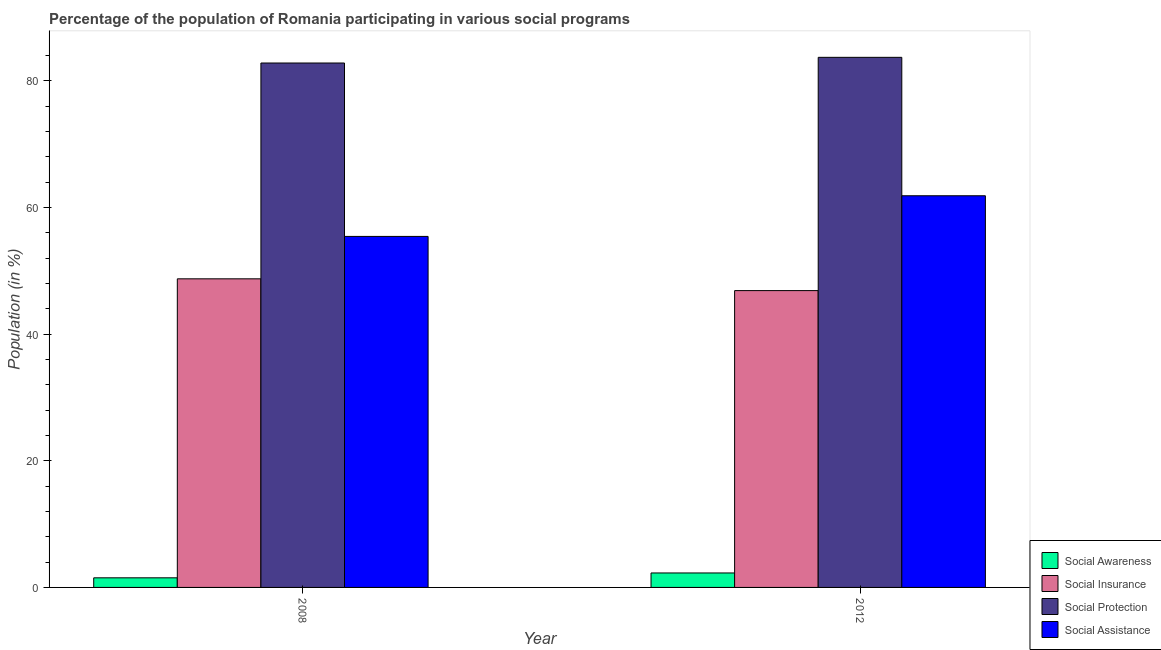How many groups of bars are there?
Offer a very short reply. 2. Are the number of bars per tick equal to the number of legend labels?
Offer a terse response. Yes. How many bars are there on the 1st tick from the left?
Ensure brevity in your answer.  4. What is the label of the 1st group of bars from the left?
Offer a very short reply. 2008. What is the participation of population in social protection programs in 2012?
Offer a terse response. 83.69. Across all years, what is the maximum participation of population in social awareness programs?
Offer a very short reply. 2.28. Across all years, what is the minimum participation of population in social insurance programs?
Your answer should be very brief. 46.86. What is the total participation of population in social awareness programs in the graph?
Offer a very short reply. 3.8. What is the difference between the participation of population in social protection programs in 2008 and that in 2012?
Provide a succinct answer. -0.9. What is the difference between the participation of population in social protection programs in 2008 and the participation of population in social assistance programs in 2012?
Provide a short and direct response. -0.9. What is the average participation of population in social insurance programs per year?
Provide a succinct answer. 47.79. In the year 2012, what is the difference between the participation of population in social awareness programs and participation of population in social insurance programs?
Keep it short and to the point. 0. In how many years, is the participation of population in social assistance programs greater than 72 %?
Offer a terse response. 0. What is the ratio of the participation of population in social awareness programs in 2008 to that in 2012?
Ensure brevity in your answer.  0.66. Is the participation of population in social insurance programs in 2008 less than that in 2012?
Ensure brevity in your answer.  No. In how many years, is the participation of population in social awareness programs greater than the average participation of population in social awareness programs taken over all years?
Offer a very short reply. 1. Is it the case that in every year, the sum of the participation of population in social assistance programs and participation of population in social insurance programs is greater than the sum of participation of population in social protection programs and participation of population in social awareness programs?
Keep it short and to the point. Yes. What does the 1st bar from the left in 2012 represents?
Your answer should be very brief. Social Awareness. What does the 3rd bar from the right in 2008 represents?
Ensure brevity in your answer.  Social Insurance. Are all the bars in the graph horizontal?
Your answer should be very brief. No. Does the graph contain grids?
Offer a very short reply. No. What is the title of the graph?
Give a very brief answer. Percentage of the population of Romania participating in various social programs . Does "Subsidies and Transfers" appear as one of the legend labels in the graph?
Provide a short and direct response. No. What is the Population (in %) of Social Awareness in 2008?
Provide a succinct answer. 1.52. What is the Population (in %) in Social Insurance in 2008?
Offer a terse response. 48.72. What is the Population (in %) of Social Protection in 2008?
Give a very brief answer. 82.79. What is the Population (in %) of Social Assistance in 2008?
Provide a succinct answer. 55.42. What is the Population (in %) in Social Awareness in 2012?
Offer a terse response. 2.28. What is the Population (in %) in Social Insurance in 2012?
Give a very brief answer. 46.86. What is the Population (in %) in Social Protection in 2012?
Give a very brief answer. 83.69. What is the Population (in %) in Social Assistance in 2012?
Provide a succinct answer. 61.83. Across all years, what is the maximum Population (in %) in Social Awareness?
Ensure brevity in your answer.  2.28. Across all years, what is the maximum Population (in %) of Social Insurance?
Your answer should be compact. 48.72. Across all years, what is the maximum Population (in %) of Social Protection?
Make the answer very short. 83.69. Across all years, what is the maximum Population (in %) of Social Assistance?
Give a very brief answer. 61.83. Across all years, what is the minimum Population (in %) of Social Awareness?
Offer a very short reply. 1.52. Across all years, what is the minimum Population (in %) in Social Insurance?
Make the answer very short. 46.86. Across all years, what is the minimum Population (in %) in Social Protection?
Provide a short and direct response. 82.79. Across all years, what is the minimum Population (in %) in Social Assistance?
Give a very brief answer. 55.42. What is the total Population (in %) of Social Awareness in the graph?
Give a very brief answer. 3.8. What is the total Population (in %) in Social Insurance in the graph?
Ensure brevity in your answer.  95.58. What is the total Population (in %) of Social Protection in the graph?
Offer a very short reply. 166.48. What is the total Population (in %) in Social Assistance in the graph?
Your answer should be very brief. 117.25. What is the difference between the Population (in %) in Social Awareness in 2008 and that in 2012?
Offer a terse response. -0.77. What is the difference between the Population (in %) in Social Insurance in 2008 and that in 2012?
Keep it short and to the point. 1.86. What is the difference between the Population (in %) in Social Protection in 2008 and that in 2012?
Keep it short and to the point. -0.9. What is the difference between the Population (in %) in Social Assistance in 2008 and that in 2012?
Your answer should be compact. -6.42. What is the difference between the Population (in %) of Social Awareness in 2008 and the Population (in %) of Social Insurance in 2012?
Your response must be concise. -45.34. What is the difference between the Population (in %) of Social Awareness in 2008 and the Population (in %) of Social Protection in 2012?
Provide a short and direct response. -82.17. What is the difference between the Population (in %) of Social Awareness in 2008 and the Population (in %) of Social Assistance in 2012?
Offer a very short reply. -60.32. What is the difference between the Population (in %) of Social Insurance in 2008 and the Population (in %) of Social Protection in 2012?
Offer a very short reply. -34.97. What is the difference between the Population (in %) of Social Insurance in 2008 and the Population (in %) of Social Assistance in 2012?
Make the answer very short. -13.11. What is the difference between the Population (in %) of Social Protection in 2008 and the Population (in %) of Social Assistance in 2012?
Give a very brief answer. 20.96. What is the average Population (in %) of Social Awareness per year?
Ensure brevity in your answer.  1.9. What is the average Population (in %) in Social Insurance per year?
Keep it short and to the point. 47.79. What is the average Population (in %) of Social Protection per year?
Offer a terse response. 83.24. What is the average Population (in %) in Social Assistance per year?
Ensure brevity in your answer.  58.62. In the year 2008, what is the difference between the Population (in %) of Social Awareness and Population (in %) of Social Insurance?
Offer a very short reply. -47.2. In the year 2008, what is the difference between the Population (in %) of Social Awareness and Population (in %) of Social Protection?
Provide a succinct answer. -81.28. In the year 2008, what is the difference between the Population (in %) of Social Awareness and Population (in %) of Social Assistance?
Offer a very short reply. -53.9. In the year 2008, what is the difference between the Population (in %) of Social Insurance and Population (in %) of Social Protection?
Give a very brief answer. -34.07. In the year 2008, what is the difference between the Population (in %) of Social Insurance and Population (in %) of Social Assistance?
Give a very brief answer. -6.7. In the year 2008, what is the difference between the Population (in %) in Social Protection and Population (in %) in Social Assistance?
Offer a very short reply. 27.38. In the year 2012, what is the difference between the Population (in %) of Social Awareness and Population (in %) of Social Insurance?
Provide a succinct answer. -44.58. In the year 2012, what is the difference between the Population (in %) of Social Awareness and Population (in %) of Social Protection?
Provide a succinct answer. -81.4. In the year 2012, what is the difference between the Population (in %) of Social Awareness and Population (in %) of Social Assistance?
Your answer should be compact. -59.55. In the year 2012, what is the difference between the Population (in %) in Social Insurance and Population (in %) in Social Protection?
Keep it short and to the point. -36.83. In the year 2012, what is the difference between the Population (in %) of Social Insurance and Population (in %) of Social Assistance?
Keep it short and to the point. -14.97. In the year 2012, what is the difference between the Population (in %) in Social Protection and Population (in %) in Social Assistance?
Provide a succinct answer. 21.86. What is the ratio of the Population (in %) of Social Awareness in 2008 to that in 2012?
Give a very brief answer. 0.66. What is the ratio of the Population (in %) in Social Insurance in 2008 to that in 2012?
Make the answer very short. 1.04. What is the ratio of the Population (in %) in Social Protection in 2008 to that in 2012?
Ensure brevity in your answer.  0.99. What is the ratio of the Population (in %) of Social Assistance in 2008 to that in 2012?
Make the answer very short. 0.9. What is the difference between the highest and the second highest Population (in %) of Social Awareness?
Make the answer very short. 0.77. What is the difference between the highest and the second highest Population (in %) in Social Insurance?
Provide a succinct answer. 1.86. What is the difference between the highest and the second highest Population (in %) in Social Protection?
Keep it short and to the point. 0.9. What is the difference between the highest and the second highest Population (in %) of Social Assistance?
Provide a short and direct response. 6.42. What is the difference between the highest and the lowest Population (in %) in Social Awareness?
Offer a terse response. 0.77. What is the difference between the highest and the lowest Population (in %) of Social Insurance?
Provide a short and direct response. 1.86. What is the difference between the highest and the lowest Population (in %) in Social Protection?
Give a very brief answer. 0.9. What is the difference between the highest and the lowest Population (in %) in Social Assistance?
Provide a succinct answer. 6.42. 